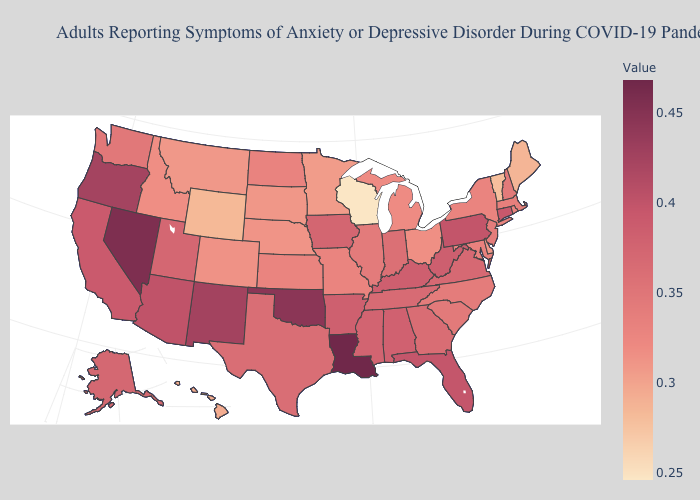Is the legend a continuous bar?
Concise answer only. Yes. Which states have the lowest value in the USA?
Write a very short answer. Wisconsin. Among the states that border Alabama , which have the lowest value?
Keep it brief. Georgia. Does Arizona have a higher value than Wyoming?
Give a very brief answer. Yes. Is the legend a continuous bar?
Answer briefly. Yes. Which states have the lowest value in the USA?
Give a very brief answer. Wisconsin. Does Louisiana have the highest value in the USA?
Quick response, please. Yes. Does Florida have a lower value than Idaho?
Write a very short answer. No. 